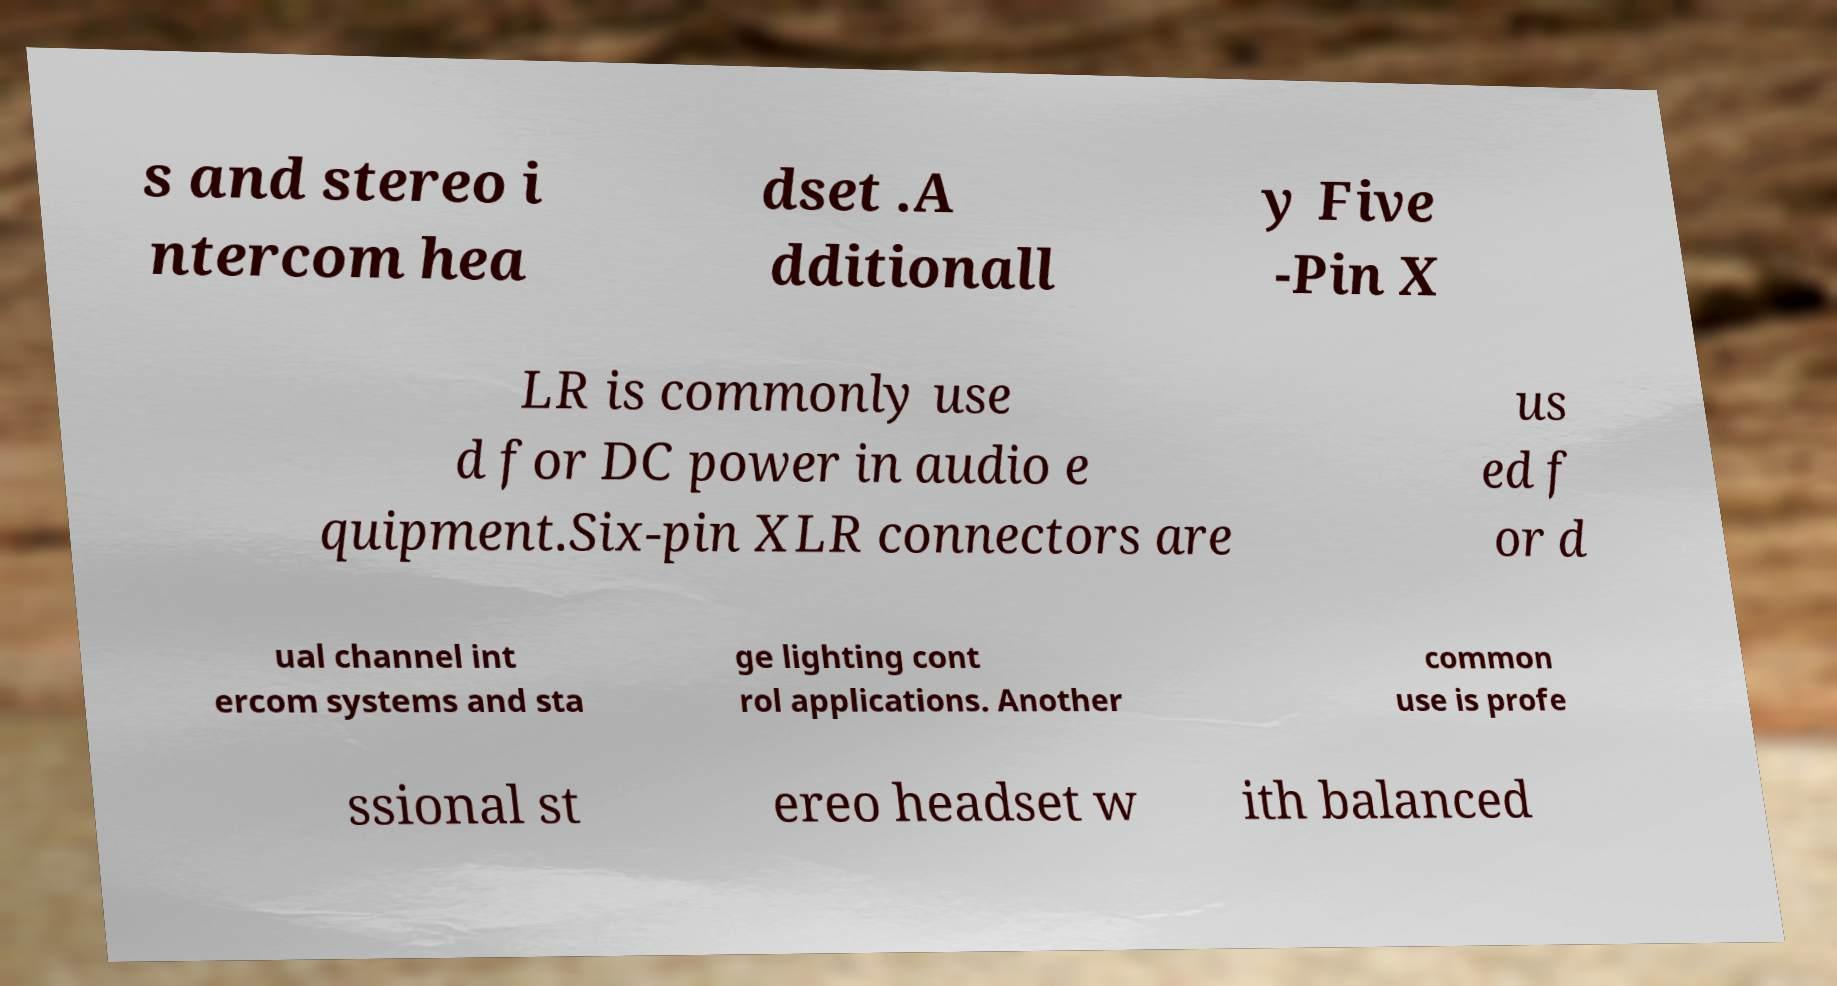Please read and relay the text visible in this image. What does it say? s and stereo i ntercom hea dset .A dditionall y Five -Pin X LR is commonly use d for DC power in audio e quipment.Six-pin XLR connectors are us ed f or d ual channel int ercom systems and sta ge lighting cont rol applications. Another common use is profe ssional st ereo headset w ith balanced 